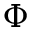<formula> <loc_0><loc_0><loc_500><loc_500>\Phi</formula> 